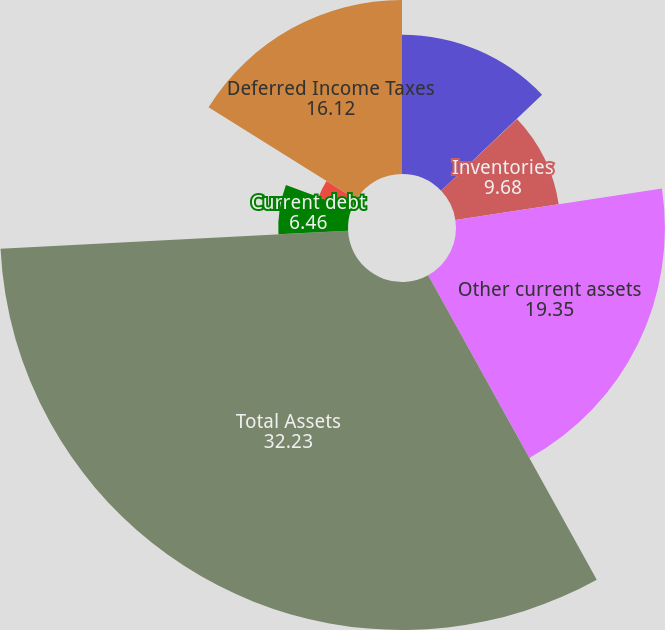<chart> <loc_0><loc_0><loc_500><loc_500><pie_chart><fcel>Cash and cash equivalents<fcel>Accounts receivable net<fcel>Inventories<fcel>Other current assets<fcel>Total Assets<fcel>Current debt<fcel>Long-Term Debt<fcel>Deferred Income Taxes<nl><fcel>12.9%<fcel>0.02%<fcel>9.68%<fcel>19.35%<fcel>32.23%<fcel>6.46%<fcel>3.24%<fcel>16.12%<nl></chart> 